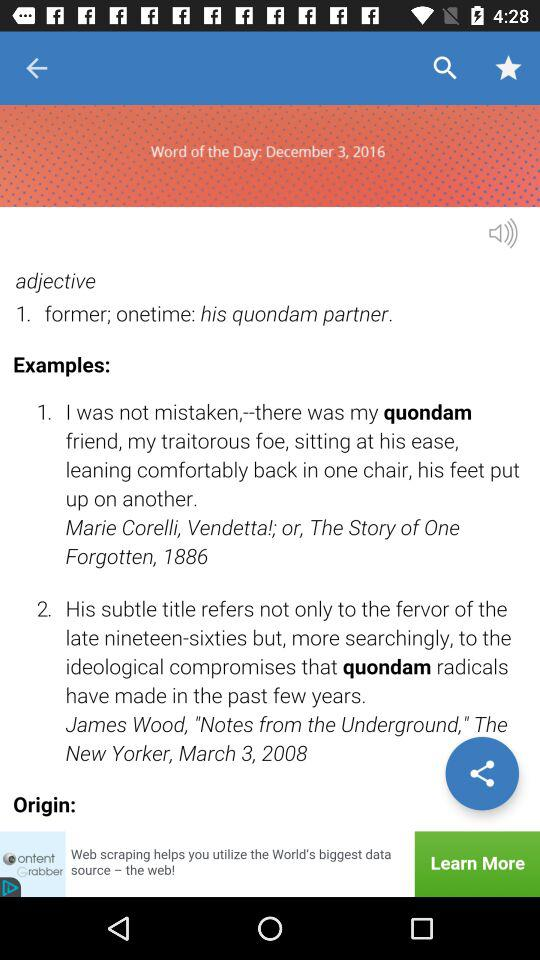How many examples are there?
Answer the question using a single word or phrase. 2 